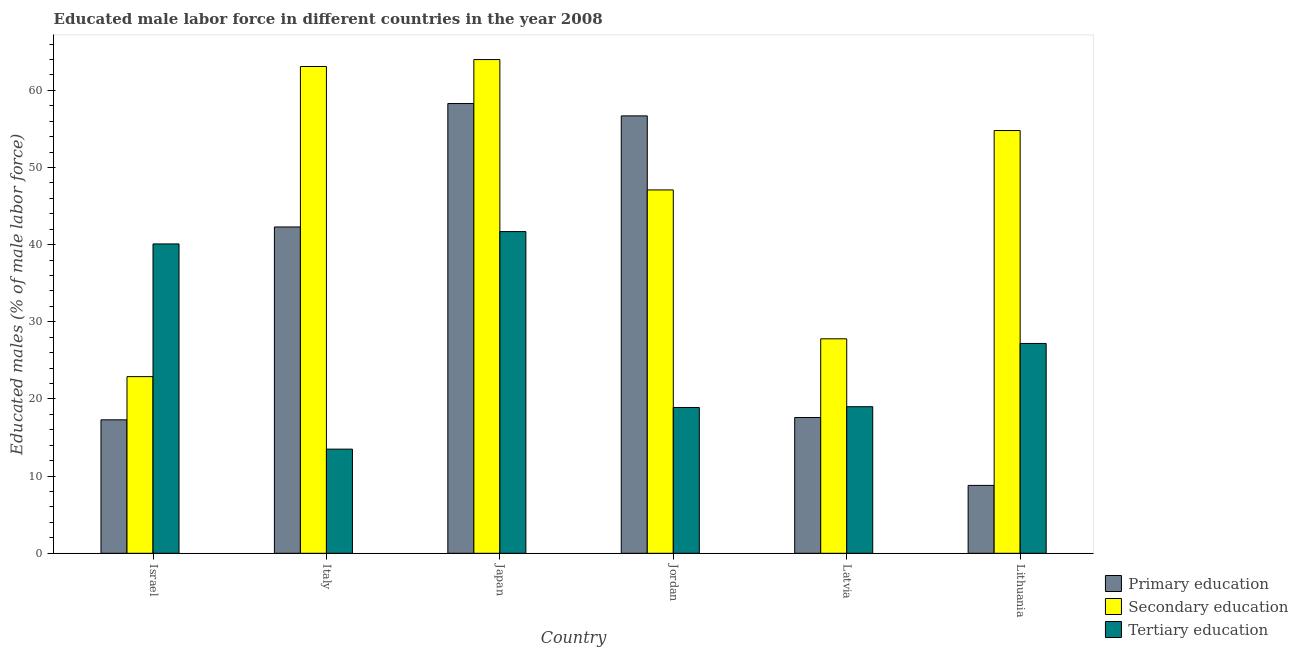Are the number of bars per tick equal to the number of legend labels?
Give a very brief answer. Yes. Are the number of bars on each tick of the X-axis equal?
Offer a terse response. Yes. What is the percentage of male labor force who received secondary education in Italy?
Provide a short and direct response. 63.1. Across all countries, what is the minimum percentage of male labor force who received primary education?
Your answer should be very brief. 8.8. In which country was the percentage of male labor force who received secondary education maximum?
Your response must be concise. Japan. In which country was the percentage of male labor force who received primary education minimum?
Your answer should be compact. Lithuania. What is the total percentage of male labor force who received secondary education in the graph?
Your answer should be compact. 279.7. What is the difference between the percentage of male labor force who received primary education in Japan and that in Jordan?
Your response must be concise. 1.6. What is the difference between the percentage of male labor force who received secondary education in Italy and the percentage of male labor force who received tertiary education in Latvia?
Keep it short and to the point. 44.1. What is the average percentage of male labor force who received secondary education per country?
Make the answer very short. 46.62. What is the difference between the percentage of male labor force who received tertiary education and percentage of male labor force who received primary education in Italy?
Your answer should be very brief. -28.8. What is the ratio of the percentage of male labor force who received primary education in Japan to that in Latvia?
Ensure brevity in your answer.  3.31. Is the percentage of male labor force who received secondary education in Israel less than that in Italy?
Offer a very short reply. Yes. What is the difference between the highest and the second highest percentage of male labor force who received primary education?
Ensure brevity in your answer.  1.6. What is the difference between the highest and the lowest percentage of male labor force who received secondary education?
Provide a succinct answer. 41.1. Is the sum of the percentage of male labor force who received secondary education in Japan and Jordan greater than the maximum percentage of male labor force who received primary education across all countries?
Offer a terse response. Yes. What does the 3rd bar from the left in Latvia represents?
Your response must be concise. Tertiary education. What does the 1st bar from the right in Jordan represents?
Ensure brevity in your answer.  Tertiary education. Is it the case that in every country, the sum of the percentage of male labor force who received primary education and percentage of male labor force who received secondary education is greater than the percentage of male labor force who received tertiary education?
Your answer should be very brief. Yes. How many bars are there?
Your response must be concise. 18. Are all the bars in the graph horizontal?
Your answer should be very brief. No. How many countries are there in the graph?
Provide a succinct answer. 6. Does the graph contain any zero values?
Your answer should be very brief. No. Does the graph contain grids?
Your response must be concise. No. How many legend labels are there?
Your answer should be compact. 3. What is the title of the graph?
Provide a short and direct response. Educated male labor force in different countries in the year 2008. Does "Nuclear sources" appear as one of the legend labels in the graph?
Your response must be concise. No. What is the label or title of the Y-axis?
Your answer should be compact. Educated males (% of male labor force). What is the Educated males (% of male labor force) of Primary education in Israel?
Keep it short and to the point. 17.3. What is the Educated males (% of male labor force) in Secondary education in Israel?
Provide a short and direct response. 22.9. What is the Educated males (% of male labor force) in Tertiary education in Israel?
Offer a terse response. 40.1. What is the Educated males (% of male labor force) in Primary education in Italy?
Keep it short and to the point. 42.3. What is the Educated males (% of male labor force) of Secondary education in Italy?
Offer a terse response. 63.1. What is the Educated males (% of male labor force) in Tertiary education in Italy?
Your response must be concise. 13.5. What is the Educated males (% of male labor force) in Primary education in Japan?
Give a very brief answer. 58.3. What is the Educated males (% of male labor force) of Tertiary education in Japan?
Your response must be concise. 41.7. What is the Educated males (% of male labor force) in Primary education in Jordan?
Make the answer very short. 56.7. What is the Educated males (% of male labor force) in Secondary education in Jordan?
Your answer should be compact. 47.1. What is the Educated males (% of male labor force) in Tertiary education in Jordan?
Provide a succinct answer. 18.9. What is the Educated males (% of male labor force) of Primary education in Latvia?
Offer a terse response. 17.6. What is the Educated males (% of male labor force) of Secondary education in Latvia?
Your answer should be compact. 27.8. What is the Educated males (% of male labor force) in Tertiary education in Latvia?
Offer a terse response. 19. What is the Educated males (% of male labor force) of Primary education in Lithuania?
Give a very brief answer. 8.8. What is the Educated males (% of male labor force) of Secondary education in Lithuania?
Your answer should be compact. 54.8. What is the Educated males (% of male labor force) in Tertiary education in Lithuania?
Offer a terse response. 27.2. Across all countries, what is the maximum Educated males (% of male labor force) in Primary education?
Provide a short and direct response. 58.3. Across all countries, what is the maximum Educated males (% of male labor force) in Secondary education?
Give a very brief answer. 64. Across all countries, what is the maximum Educated males (% of male labor force) in Tertiary education?
Your answer should be very brief. 41.7. Across all countries, what is the minimum Educated males (% of male labor force) of Primary education?
Give a very brief answer. 8.8. Across all countries, what is the minimum Educated males (% of male labor force) of Secondary education?
Provide a succinct answer. 22.9. Across all countries, what is the minimum Educated males (% of male labor force) in Tertiary education?
Your answer should be very brief. 13.5. What is the total Educated males (% of male labor force) of Primary education in the graph?
Offer a very short reply. 201. What is the total Educated males (% of male labor force) of Secondary education in the graph?
Offer a very short reply. 279.7. What is the total Educated males (% of male labor force) in Tertiary education in the graph?
Your answer should be very brief. 160.4. What is the difference between the Educated males (% of male labor force) of Primary education in Israel and that in Italy?
Provide a succinct answer. -25. What is the difference between the Educated males (% of male labor force) in Secondary education in Israel and that in Italy?
Offer a terse response. -40.2. What is the difference between the Educated males (% of male labor force) in Tertiary education in Israel and that in Italy?
Provide a succinct answer. 26.6. What is the difference between the Educated males (% of male labor force) in Primary education in Israel and that in Japan?
Provide a short and direct response. -41. What is the difference between the Educated males (% of male labor force) of Secondary education in Israel and that in Japan?
Offer a very short reply. -41.1. What is the difference between the Educated males (% of male labor force) of Tertiary education in Israel and that in Japan?
Provide a succinct answer. -1.6. What is the difference between the Educated males (% of male labor force) of Primary education in Israel and that in Jordan?
Your answer should be very brief. -39.4. What is the difference between the Educated males (% of male labor force) of Secondary education in Israel and that in Jordan?
Offer a very short reply. -24.2. What is the difference between the Educated males (% of male labor force) in Tertiary education in Israel and that in Jordan?
Keep it short and to the point. 21.2. What is the difference between the Educated males (% of male labor force) of Secondary education in Israel and that in Latvia?
Make the answer very short. -4.9. What is the difference between the Educated males (% of male labor force) in Tertiary education in Israel and that in Latvia?
Give a very brief answer. 21.1. What is the difference between the Educated males (% of male labor force) of Primary education in Israel and that in Lithuania?
Ensure brevity in your answer.  8.5. What is the difference between the Educated males (% of male labor force) in Secondary education in Israel and that in Lithuania?
Offer a terse response. -31.9. What is the difference between the Educated males (% of male labor force) of Tertiary education in Israel and that in Lithuania?
Ensure brevity in your answer.  12.9. What is the difference between the Educated males (% of male labor force) of Primary education in Italy and that in Japan?
Give a very brief answer. -16. What is the difference between the Educated males (% of male labor force) in Secondary education in Italy and that in Japan?
Offer a terse response. -0.9. What is the difference between the Educated males (% of male labor force) of Tertiary education in Italy and that in Japan?
Offer a very short reply. -28.2. What is the difference between the Educated males (% of male labor force) in Primary education in Italy and that in Jordan?
Your answer should be compact. -14.4. What is the difference between the Educated males (% of male labor force) of Secondary education in Italy and that in Jordan?
Ensure brevity in your answer.  16. What is the difference between the Educated males (% of male labor force) of Tertiary education in Italy and that in Jordan?
Give a very brief answer. -5.4. What is the difference between the Educated males (% of male labor force) of Primary education in Italy and that in Latvia?
Offer a terse response. 24.7. What is the difference between the Educated males (% of male labor force) of Secondary education in Italy and that in Latvia?
Keep it short and to the point. 35.3. What is the difference between the Educated males (% of male labor force) of Primary education in Italy and that in Lithuania?
Provide a succinct answer. 33.5. What is the difference between the Educated males (% of male labor force) in Secondary education in Italy and that in Lithuania?
Your answer should be very brief. 8.3. What is the difference between the Educated males (% of male labor force) of Tertiary education in Italy and that in Lithuania?
Your answer should be compact. -13.7. What is the difference between the Educated males (% of male labor force) in Secondary education in Japan and that in Jordan?
Make the answer very short. 16.9. What is the difference between the Educated males (% of male labor force) in Tertiary education in Japan and that in Jordan?
Offer a very short reply. 22.8. What is the difference between the Educated males (% of male labor force) in Primary education in Japan and that in Latvia?
Offer a terse response. 40.7. What is the difference between the Educated males (% of male labor force) in Secondary education in Japan and that in Latvia?
Your answer should be very brief. 36.2. What is the difference between the Educated males (% of male labor force) of Tertiary education in Japan and that in Latvia?
Give a very brief answer. 22.7. What is the difference between the Educated males (% of male labor force) of Primary education in Japan and that in Lithuania?
Provide a short and direct response. 49.5. What is the difference between the Educated males (% of male labor force) of Secondary education in Japan and that in Lithuania?
Offer a very short reply. 9.2. What is the difference between the Educated males (% of male labor force) in Primary education in Jordan and that in Latvia?
Give a very brief answer. 39.1. What is the difference between the Educated males (% of male labor force) of Secondary education in Jordan and that in Latvia?
Your answer should be very brief. 19.3. What is the difference between the Educated males (% of male labor force) in Primary education in Jordan and that in Lithuania?
Your answer should be compact. 47.9. What is the difference between the Educated males (% of male labor force) in Secondary education in Jordan and that in Lithuania?
Ensure brevity in your answer.  -7.7. What is the difference between the Educated males (% of male labor force) in Tertiary education in Jordan and that in Lithuania?
Your answer should be compact. -8.3. What is the difference between the Educated males (% of male labor force) of Secondary education in Latvia and that in Lithuania?
Provide a succinct answer. -27. What is the difference between the Educated males (% of male labor force) of Tertiary education in Latvia and that in Lithuania?
Ensure brevity in your answer.  -8.2. What is the difference between the Educated males (% of male labor force) of Primary education in Israel and the Educated males (% of male labor force) of Secondary education in Italy?
Offer a terse response. -45.8. What is the difference between the Educated males (% of male labor force) in Secondary education in Israel and the Educated males (% of male labor force) in Tertiary education in Italy?
Your answer should be compact. 9.4. What is the difference between the Educated males (% of male labor force) in Primary education in Israel and the Educated males (% of male labor force) in Secondary education in Japan?
Offer a terse response. -46.7. What is the difference between the Educated males (% of male labor force) in Primary education in Israel and the Educated males (% of male labor force) in Tertiary education in Japan?
Give a very brief answer. -24.4. What is the difference between the Educated males (% of male labor force) in Secondary education in Israel and the Educated males (% of male labor force) in Tertiary education in Japan?
Provide a succinct answer. -18.8. What is the difference between the Educated males (% of male labor force) of Primary education in Israel and the Educated males (% of male labor force) of Secondary education in Jordan?
Keep it short and to the point. -29.8. What is the difference between the Educated males (% of male labor force) of Secondary education in Israel and the Educated males (% of male labor force) of Tertiary education in Jordan?
Ensure brevity in your answer.  4. What is the difference between the Educated males (% of male labor force) of Secondary education in Israel and the Educated males (% of male labor force) of Tertiary education in Latvia?
Provide a succinct answer. 3.9. What is the difference between the Educated males (% of male labor force) of Primary education in Israel and the Educated males (% of male labor force) of Secondary education in Lithuania?
Provide a short and direct response. -37.5. What is the difference between the Educated males (% of male labor force) of Primary education in Israel and the Educated males (% of male labor force) of Tertiary education in Lithuania?
Provide a succinct answer. -9.9. What is the difference between the Educated males (% of male labor force) in Secondary education in Israel and the Educated males (% of male labor force) in Tertiary education in Lithuania?
Offer a very short reply. -4.3. What is the difference between the Educated males (% of male labor force) of Primary education in Italy and the Educated males (% of male labor force) of Secondary education in Japan?
Offer a very short reply. -21.7. What is the difference between the Educated males (% of male labor force) of Secondary education in Italy and the Educated males (% of male labor force) of Tertiary education in Japan?
Your answer should be compact. 21.4. What is the difference between the Educated males (% of male labor force) of Primary education in Italy and the Educated males (% of male labor force) of Tertiary education in Jordan?
Ensure brevity in your answer.  23.4. What is the difference between the Educated males (% of male labor force) in Secondary education in Italy and the Educated males (% of male labor force) in Tertiary education in Jordan?
Ensure brevity in your answer.  44.2. What is the difference between the Educated males (% of male labor force) of Primary education in Italy and the Educated males (% of male labor force) of Secondary education in Latvia?
Your answer should be compact. 14.5. What is the difference between the Educated males (% of male labor force) of Primary education in Italy and the Educated males (% of male labor force) of Tertiary education in Latvia?
Keep it short and to the point. 23.3. What is the difference between the Educated males (% of male labor force) of Secondary education in Italy and the Educated males (% of male labor force) of Tertiary education in Latvia?
Your answer should be very brief. 44.1. What is the difference between the Educated males (% of male labor force) in Secondary education in Italy and the Educated males (% of male labor force) in Tertiary education in Lithuania?
Your answer should be very brief. 35.9. What is the difference between the Educated males (% of male labor force) of Primary education in Japan and the Educated males (% of male labor force) of Secondary education in Jordan?
Ensure brevity in your answer.  11.2. What is the difference between the Educated males (% of male labor force) in Primary education in Japan and the Educated males (% of male labor force) in Tertiary education in Jordan?
Your answer should be compact. 39.4. What is the difference between the Educated males (% of male labor force) of Secondary education in Japan and the Educated males (% of male labor force) of Tertiary education in Jordan?
Offer a very short reply. 45.1. What is the difference between the Educated males (% of male labor force) of Primary education in Japan and the Educated males (% of male labor force) of Secondary education in Latvia?
Provide a short and direct response. 30.5. What is the difference between the Educated males (% of male labor force) in Primary education in Japan and the Educated males (% of male labor force) in Tertiary education in Latvia?
Provide a succinct answer. 39.3. What is the difference between the Educated males (% of male labor force) of Primary education in Japan and the Educated males (% of male labor force) of Secondary education in Lithuania?
Ensure brevity in your answer.  3.5. What is the difference between the Educated males (% of male labor force) of Primary education in Japan and the Educated males (% of male labor force) of Tertiary education in Lithuania?
Keep it short and to the point. 31.1. What is the difference between the Educated males (% of male labor force) of Secondary education in Japan and the Educated males (% of male labor force) of Tertiary education in Lithuania?
Keep it short and to the point. 36.8. What is the difference between the Educated males (% of male labor force) of Primary education in Jordan and the Educated males (% of male labor force) of Secondary education in Latvia?
Ensure brevity in your answer.  28.9. What is the difference between the Educated males (% of male labor force) of Primary education in Jordan and the Educated males (% of male labor force) of Tertiary education in Latvia?
Your answer should be very brief. 37.7. What is the difference between the Educated males (% of male labor force) in Secondary education in Jordan and the Educated males (% of male labor force) in Tertiary education in Latvia?
Give a very brief answer. 28.1. What is the difference between the Educated males (% of male labor force) of Primary education in Jordan and the Educated males (% of male labor force) of Tertiary education in Lithuania?
Provide a short and direct response. 29.5. What is the difference between the Educated males (% of male labor force) in Secondary education in Jordan and the Educated males (% of male labor force) in Tertiary education in Lithuania?
Offer a very short reply. 19.9. What is the difference between the Educated males (% of male labor force) in Primary education in Latvia and the Educated males (% of male labor force) in Secondary education in Lithuania?
Offer a terse response. -37.2. What is the difference between the Educated males (% of male labor force) in Primary education in Latvia and the Educated males (% of male labor force) in Tertiary education in Lithuania?
Your response must be concise. -9.6. What is the difference between the Educated males (% of male labor force) of Secondary education in Latvia and the Educated males (% of male labor force) of Tertiary education in Lithuania?
Your response must be concise. 0.6. What is the average Educated males (% of male labor force) of Primary education per country?
Provide a succinct answer. 33.5. What is the average Educated males (% of male labor force) in Secondary education per country?
Ensure brevity in your answer.  46.62. What is the average Educated males (% of male labor force) in Tertiary education per country?
Make the answer very short. 26.73. What is the difference between the Educated males (% of male labor force) of Primary education and Educated males (% of male labor force) of Secondary education in Israel?
Provide a succinct answer. -5.6. What is the difference between the Educated males (% of male labor force) in Primary education and Educated males (% of male labor force) in Tertiary education in Israel?
Provide a succinct answer. -22.8. What is the difference between the Educated males (% of male labor force) in Secondary education and Educated males (% of male labor force) in Tertiary education in Israel?
Your answer should be compact. -17.2. What is the difference between the Educated males (% of male labor force) of Primary education and Educated males (% of male labor force) of Secondary education in Italy?
Your answer should be very brief. -20.8. What is the difference between the Educated males (% of male labor force) in Primary education and Educated males (% of male labor force) in Tertiary education in Italy?
Give a very brief answer. 28.8. What is the difference between the Educated males (% of male labor force) in Secondary education and Educated males (% of male labor force) in Tertiary education in Italy?
Keep it short and to the point. 49.6. What is the difference between the Educated males (% of male labor force) of Secondary education and Educated males (% of male labor force) of Tertiary education in Japan?
Ensure brevity in your answer.  22.3. What is the difference between the Educated males (% of male labor force) in Primary education and Educated males (% of male labor force) in Secondary education in Jordan?
Your answer should be very brief. 9.6. What is the difference between the Educated males (% of male labor force) in Primary education and Educated males (% of male labor force) in Tertiary education in Jordan?
Keep it short and to the point. 37.8. What is the difference between the Educated males (% of male labor force) in Secondary education and Educated males (% of male labor force) in Tertiary education in Jordan?
Make the answer very short. 28.2. What is the difference between the Educated males (% of male labor force) in Primary education and Educated males (% of male labor force) in Tertiary education in Latvia?
Keep it short and to the point. -1.4. What is the difference between the Educated males (% of male labor force) in Primary education and Educated males (% of male labor force) in Secondary education in Lithuania?
Your response must be concise. -46. What is the difference between the Educated males (% of male labor force) of Primary education and Educated males (% of male labor force) of Tertiary education in Lithuania?
Keep it short and to the point. -18.4. What is the difference between the Educated males (% of male labor force) of Secondary education and Educated males (% of male labor force) of Tertiary education in Lithuania?
Keep it short and to the point. 27.6. What is the ratio of the Educated males (% of male labor force) of Primary education in Israel to that in Italy?
Your response must be concise. 0.41. What is the ratio of the Educated males (% of male labor force) of Secondary education in Israel to that in Italy?
Keep it short and to the point. 0.36. What is the ratio of the Educated males (% of male labor force) in Tertiary education in Israel to that in Italy?
Provide a short and direct response. 2.97. What is the ratio of the Educated males (% of male labor force) in Primary education in Israel to that in Japan?
Offer a terse response. 0.3. What is the ratio of the Educated males (% of male labor force) in Secondary education in Israel to that in Japan?
Your answer should be compact. 0.36. What is the ratio of the Educated males (% of male labor force) of Tertiary education in Israel to that in Japan?
Your response must be concise. 0.96. What is the ratio of the Educated males (% of male labor force) in Primary education in Israel to that in Jordan?
Offer a very short reply. 0.31. What is the ratio of the Educated males (% of male labor force) of Secondary education in Israel to that in Jordan?
Make the answer very short. 0.49. What is the ratio of the Educated males (% of male labor force) in Tertiary education in Israel to that in Jordan?
Provide a short and direct response. 2.12. What is the ratio of the Educated males (% of male labor force) of Secondary education in Israel to that in Latvia?
Provide a succinct answer. 0.82. What is the ratio of the Educated males (% of male labor force) of Tertiary education in Israel to that in Latvia?
Keep it short and to the point. 2.11. What is the ratio of the Educated males (% of male labor force) of Primary education in Israel to that in Lithuania?
Make the answer very short. 1.97. What is the ratio of the Educated males (% of male labor force) in Secondary education in Israel to that in Lithuania?
Offer a very short reply. 0.42. What is the ratio of the Educated males (% of male labor force) in Tertiary education in Israel to that in Lithuania?
Provide a succinct answer. 1.47. What is the ratio of the Educated males (% of male labor force) of Primary education in Italy to that in Japan?
Ensure brevity in your answer.  0.73. What is the ratio of the Educated males (% of male labor force) in Secondary education in Italy to that in Japan?
Give a very brief answer. 0.99. What is the ratio of the Educated males (% of male labor force) of Tertiary education in Italy to that in Japan?
Make the answer very short. 0.32. What is the ratio of the Educated males (% of male labor force) of Primary education in Italy to that in Jordan?
Your answer should be very brief. 0.75. What is the ratio of the Educated males (% of male labor force) in Secondary education in Italy to that in Jordan?
Provide a succinct answer. 1.34. What is the ratio of the Educated males (% of male labor force) of Primary education in Italy to that in Latvia?
Offer a terse response. 2.4. What is the ratio of the Educated males (% of male labor force) of Secondary education in Italy to that in Latvia?
Offer a terse response. 2.27. What is the ratio of the Educated males (% of male labor force) of Tertiary education in Italy to that in Latvia?
Your response must be concise. 0.71. What is the ratio of the Educated males (% of male labor force) of Primary education in Italy to that in Lithuania?
Your response must be concise. 4.81. What is the ratio of the Educated males (% of male labor force) of Secondary education in Italy to that in Lithuania?
Provide a succinct answer. 1.15. What is the ratio of the Educated males (% of male labor force) in Tertiary education in Italy to that in Lithuania?
Offer a very short reply. 0.5. What is the ratio of the Educated males (% of male labor force) of Primary education in Japan to that in Jordan?
Give a very brief answer. 1.03. What is the ratio of the Educated males (% of male labor force) of Secondary education in Japan to that in Jordan?
Your response must be concise. 1.36. What is the ratio of the Educated males (% of male labor force) in Tertiary education in Japan to that in Jordan?
Provide a succinct answer. 2.21. What is the ratio of the Educated males (% of male labor force) in Primary education in Japan to that in Latvia?
Offer a very short reply. 3.31. What is the ratio of the Educated males (% of male labor force) in Secondary education in Japan to that in Latvia?
Your response must be concise. 2.3. What is the ratio of the Educated males (% of male labor force) in Tertiary education in Japan to that in Latvia?
Make the answer very short. 2.19. What is the ratio of the Educated males (% of male labor force) of Primary education in Japan to that in Lithuania?
Ensure brevity in your answer.  6.62. What is the ratio of the Educated males (% of male labor force) in Secondary education in Japan to that in Lithuania?
Make the answer very short. 1.17. What is the ratio of the Educated males (% of male labor force) in Tertiary education in Japan to that in Lithuania?
Provide a short and direct response. 1.53. What is the ratio of the Educated males (% of male labor force) of Primary education in Jordan to that in Latvia?
Ensure brevity in your answer.  3.22. What is the ratio of the Educated males (% of male labor force) of Secondary education in Jordan to that in Latvia?
Offer a very short reply. 1.69. What is the ratio of the Educated males (% of male labor force) in Tertiary education in Jordan to that in Latvia?
Your answer should be compact. 0.99. What is the ratio of the Educated males (% of male labor force) of Primary education in Jordan to that in Lithuania?
Your answer should be very brief. 6.44. What is the ratio of the Educated males (% of male labor force) in Secondary education in Jordan to that in Lithuania?
Offer a very short reply. 0.86. What is the ratio of the Educated males (% of male labor force) of Tertiary education in Jordan to that in Lithuania?
Give a very brief answer. 0.69. What is the ratio of the Educated males (% of male labor force) of Primary education in Latvia to that in Lithuania?
Keep it short and to the point. 2. What is the ratio of the Educated males (% of male labor force) of Secondary education in Latvia to that in Lithuania?
Ensure brevity in your answer.  0.51. What is the ratio of the Educated males (% of male labor force) in Tertiary education in Latvia to that in Lithuania?
Make the answer very short. 0.7. What is the difference between the highest and the second highest Educated males (% of male labor force) in Primary education?
Your answer should be compact. 1.6. What is the difference between the highest and the second highest Educated males (% of male labor force) of Secondary education?
Your answer should be very brief. 0.9. What is the difference between the highest and the lowest Educated males (% of male labor force) in Primary education?
Keep it short and to the point. 49.5. What is the difference between the highest and the lowest Educated males (% of male labor force) of Secondary education?
Offer a very short reply. 41.1. What is the difference between the highest and the lowest Educated males (% of male labor force) of Tertiary education?
Your response must be concise. 28.2. 